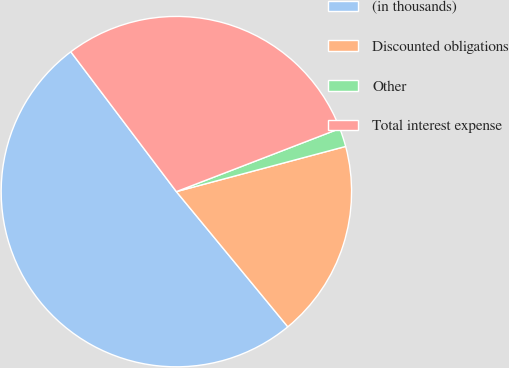<chart> <loc_0><loc_0><loc_500><loc_500><pie_chart><fcel>(in thousands)<fcel>Discounted obligations<fcel>Other<fcel>Total interest expense<nl><fcel>50.68%<fcel>18.18%<fcel>1.71%<fcel>29.43%<nl></chart> 